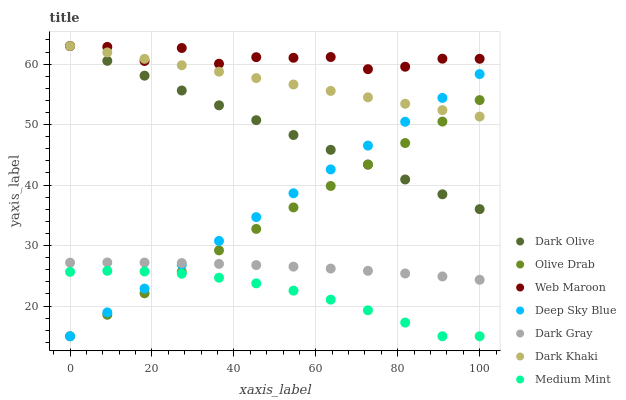Does Medium Mint have the minimum area under the curve?
Answer yes or no. Yes. Does Web Maroon have the maximum area under the curve?
Answer yes or no. Yes. Does Dark Khaki have the minimum area under the curve?
Answer yes or no. No. Does Dark Khaki have the maximum area under the curve?
Answer yes or no. No. Is Dark Khaki the smoothest?
Answer yes or no. Yes. Is Web Maroon the roughest?
Answer yes or no. Yes. Is Dark Olive the smoothest?
Answer yes or no. No. Is Dark Olive the roughest?
Answer yes or no. No. Does Medium Mint have the lowest value?
Answer yes or no. Yes. Does Dark Khaki have the lowest value?
Answer yes or no. No. Does Web Maroon have the highest value?
Answer yes or no. Yes. Does Dark Gray have the highest value?
Answer yes or no. No. Is Medium Mint less than Dark Olive?
Answer yes or no. Yes. Is Web Maroon greater than Dark Gray?
Answer yes or no. Yes. Does Dark Olive intersect Olive Drab?
Answer yes or no. Yes. Is Dark Olive less than Olive Drab?
Answer yes or no. No. Is Dark Olive greater than Olive Drab?
Answer yes or no. No. Does Medium Mint intersect Dark Olive?
Answer yes or no. No. 